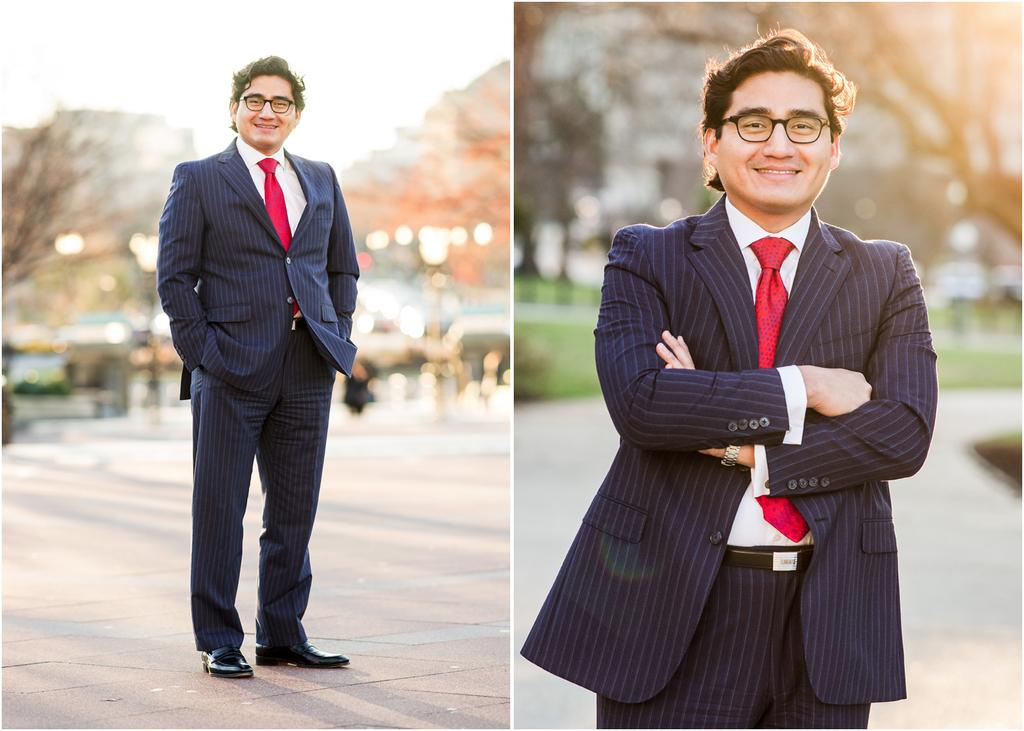What is the main subject of the image? There is a person in the image. What is the person doing in the image? The person is standing and smiling. Can you describe the background of the image? The background of the image is blurry. Reasoning: Let'ing: Let's think step by step in order to produce the conversation. We start by identifying the main subject of the image, which is the person. Then, we describe the person's actions and expressions, noting that they are standing and smiling. Finally, we describe the background of the image, which is blurry. Absurd Question/Answer: What type of fowl can be seen sitting on the desk in the image? There is no desk or fowl present in the image; it features a person standing and smiling with a blurry background. What type of fowl can be seen sitting on the desk in the image? There is no desk or fowl present in the image; it features a person standing and smiling with a blurry background. 